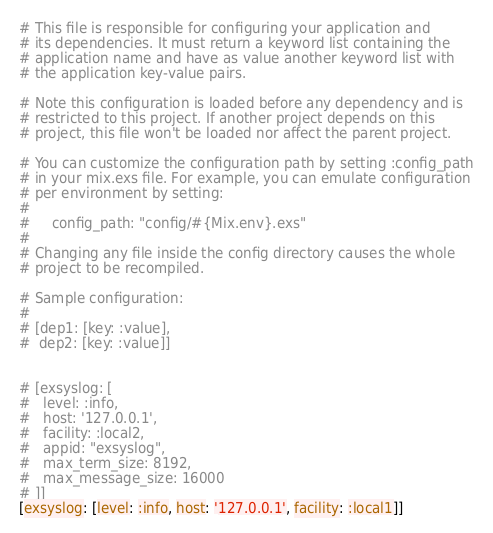<code> <loc_0><loc_0><loc_500><loc_500><_Elixir_># This file is responsible for configuring your application and
# its dependencies. It must return a keyword list containing the
# application name and have as value another keyword list with
# the application key-value pairs.

# Note this configuration is loaded before any dependency and is
# restricted to this project. If another project depends on this
# project, this file won't be loaded nor affect the parent project.

# You can customize the configuration path by setting :config_path
# in your mix.exs file. For example, you can emulate configuration
# per environment by setting:
#
#     config_path: "config/#{Mix.env}.exs"
#
# Changing any file inside the config directory causes the whole
# project to be recompiled.

# Sample configuration:
#
# [dep1: [key: :value],
#  dep2: [key: :value]]


# [exsyslog: [
#   level: :info, 
#   host: '127.0.0.1', 
#   facility: :local2,
#   appid: "exsyslog",
#   max_term_size: 8192,
#   max_message_size: 16000
# ]]
[exsyslog: [level: :info, host: '127.0.0.1', facility: :local1]]
</code> 